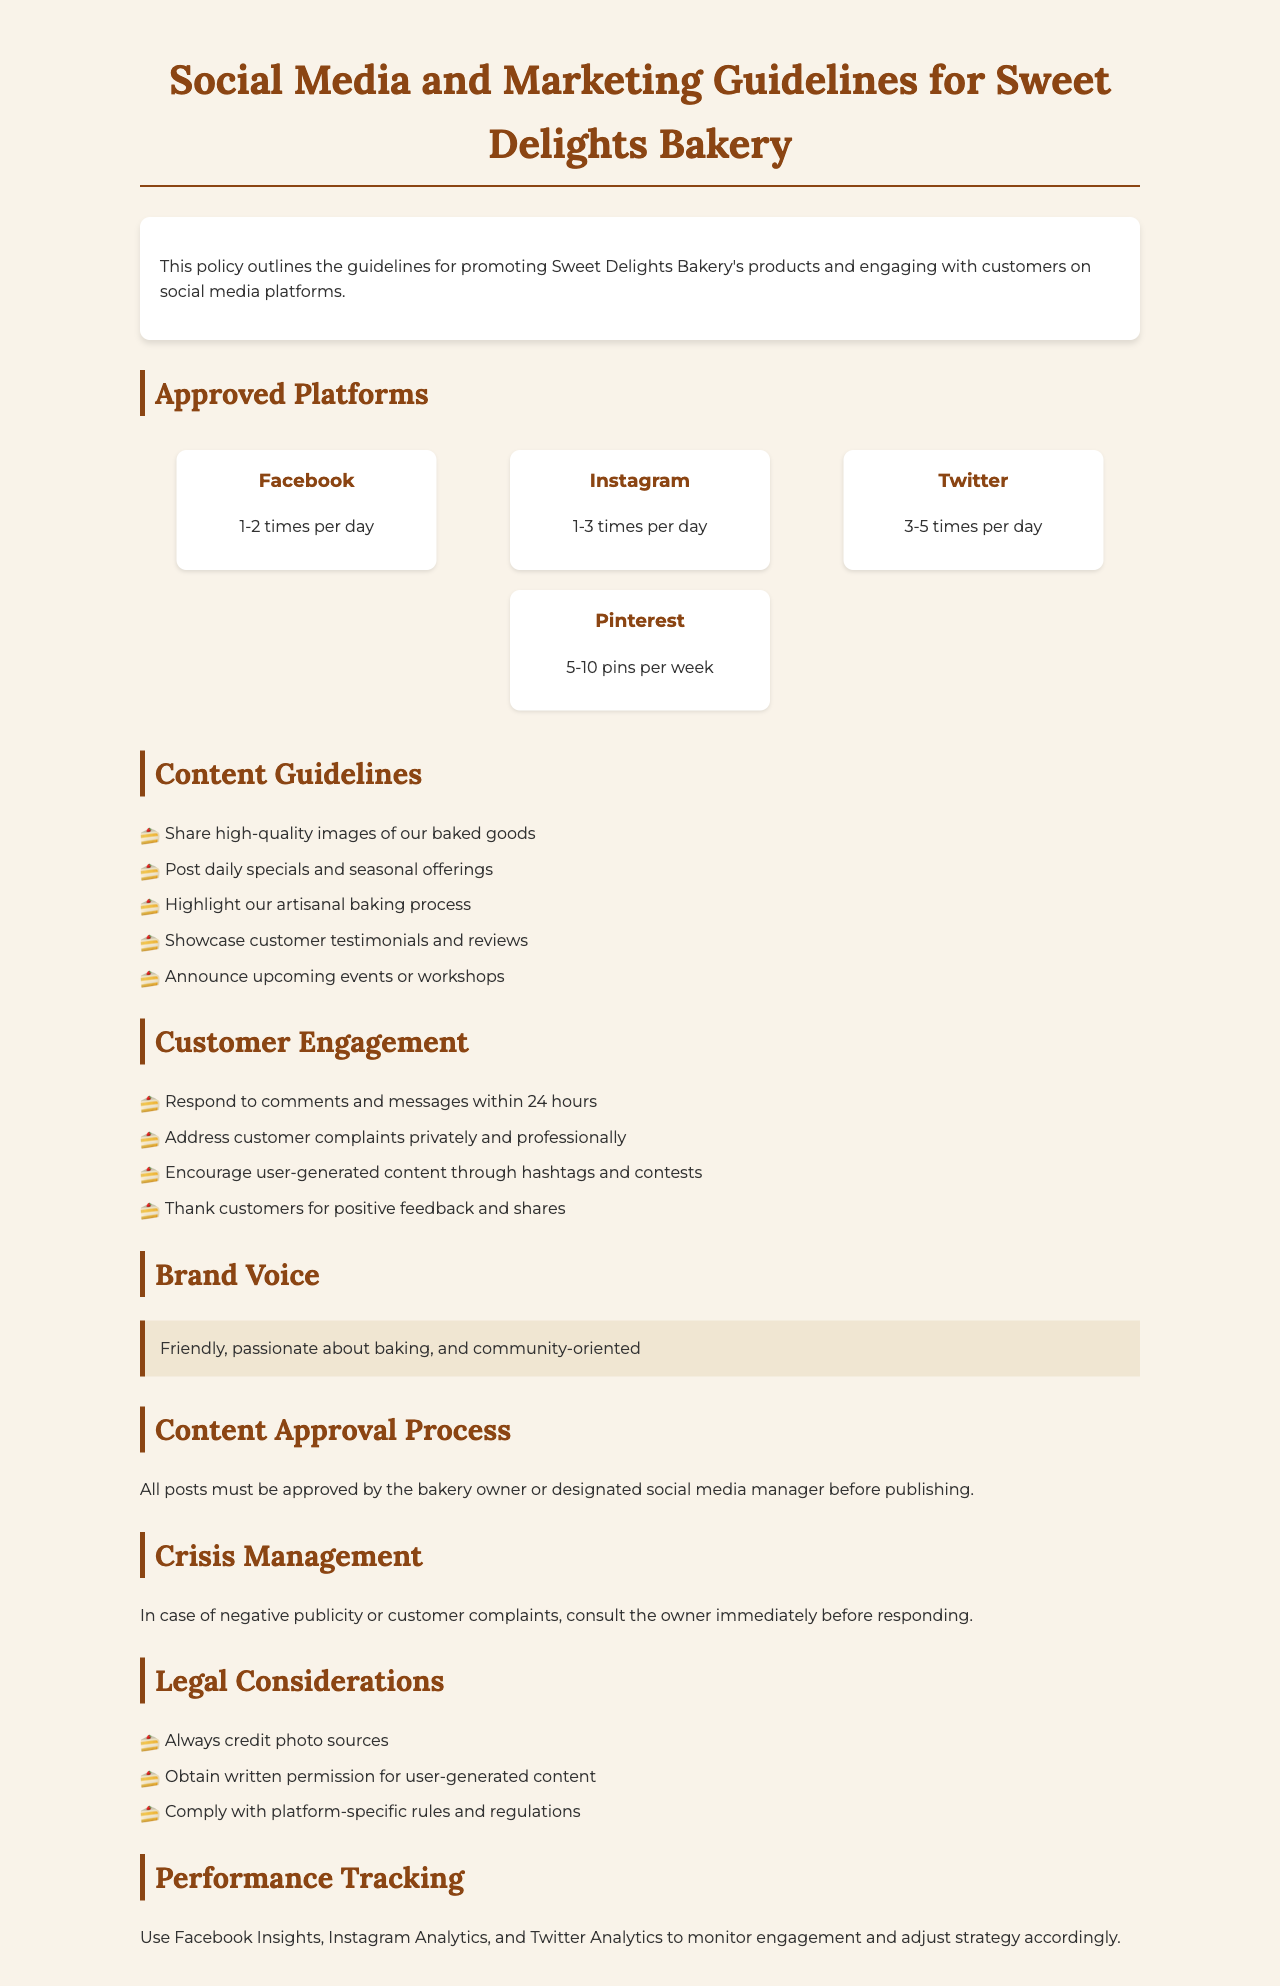what is the title of the document? The title of the document is presented at the top of the rendered page.
Answer: Social Media and Marketing Guidelines for Sweet Delights Bakery how many times per day should we post on Instagram? The recommended posting frequency for Instagram is specified in the document.
Answer: 1-3 times per day what should be included in customer engagement according to the guidelines? The document outlines specific actions under the customer engagement section.
Answer: Respond to comments and messages within 24 hours what is the brand voice described in the document? The document provides a description of the desired brand voice.
Answer: Friendly, passionate about baking, and community-oriented who must approve all posts before publishing? The document specifies who is responsible for content approval.
Answer: Bakery owner or designated social media manager how many pins should be posted on Pinterest per week? The document states the recommended frequency for posting on Pinterest.
Answer: 5-10 pins per week what should you do in case of negative publicity? The document outlines the steps to take in response to negative publicity.
Answer: Consult the owner immediately before responding what is the highlight of the content approval process? The document emphasizes a key point about content approval.
Answer: All posts must be approved before publishing 